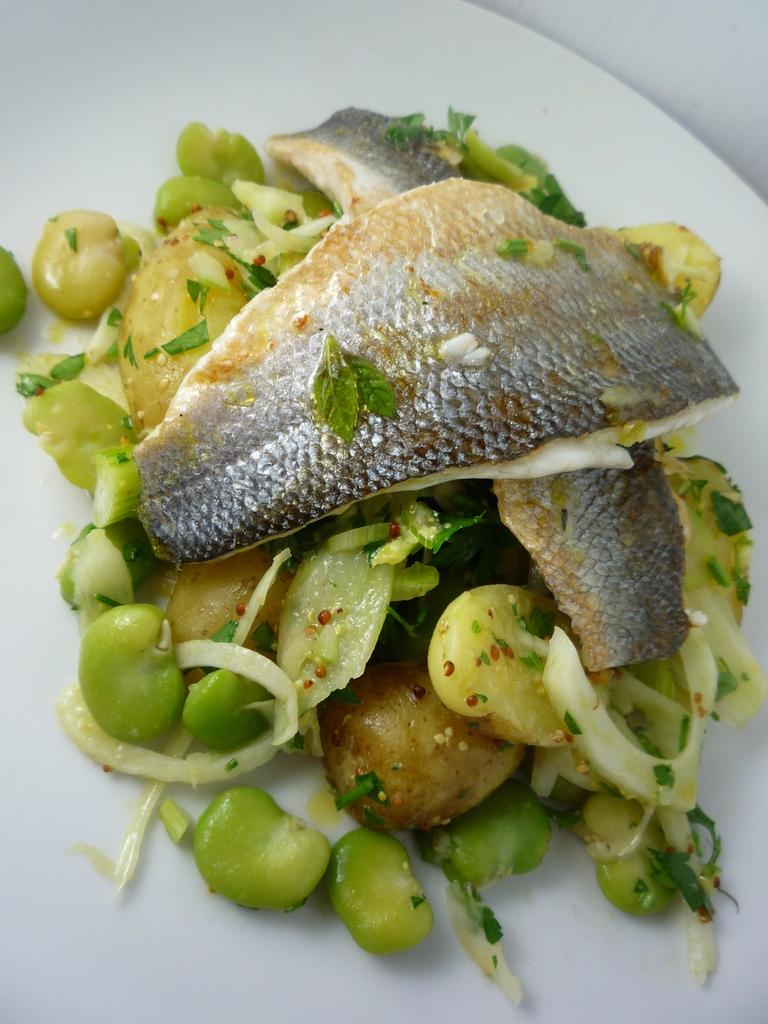What types of objects are in the center of the image? There are food items in the center of the image. Can you describe the food items in the image? Unfortunately, the provided facts do not give any specific details about the food items. How many food items are visible in the image? The number of food items cannot be determined from the provided facts. What type of pet can be seen playing with a quartz crystal in the image? There is no pet or quartz crystal present in the image; it only features food items in the center. 